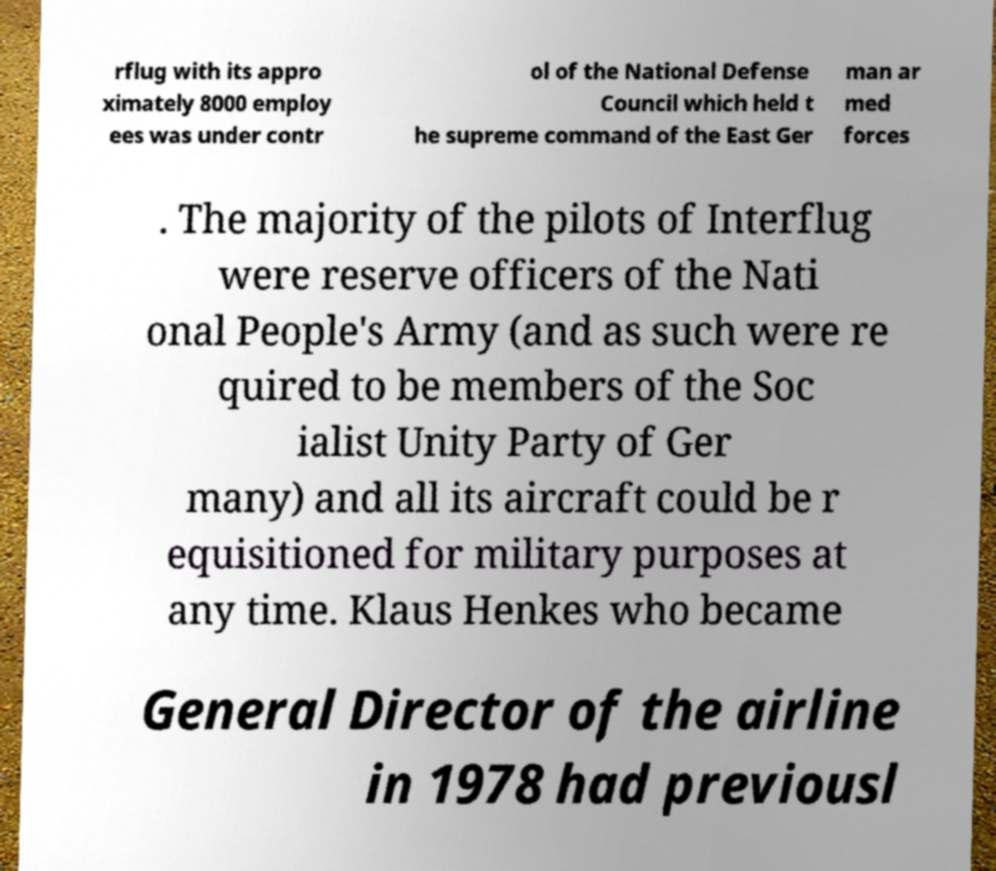Can you read and provide the text displayed in the image?This photo seems to have some interesting text. Can you extract and type it out for me? rflug with its appro ximately 8000 employ ees was under contr ol of the National Defense Council which held t he supreme command of the East Ger man ar med forces . The majority of the pilots of Interflug were reserve officers of the Nati onal People's Army (and as such were re quired to be members of the Soc ialist Unity Party of Ger many) and all its aircraft could be r equisitioned for military purposes at any time. Klaus Henkes who became General Director of the airline in 1978 had previousl 